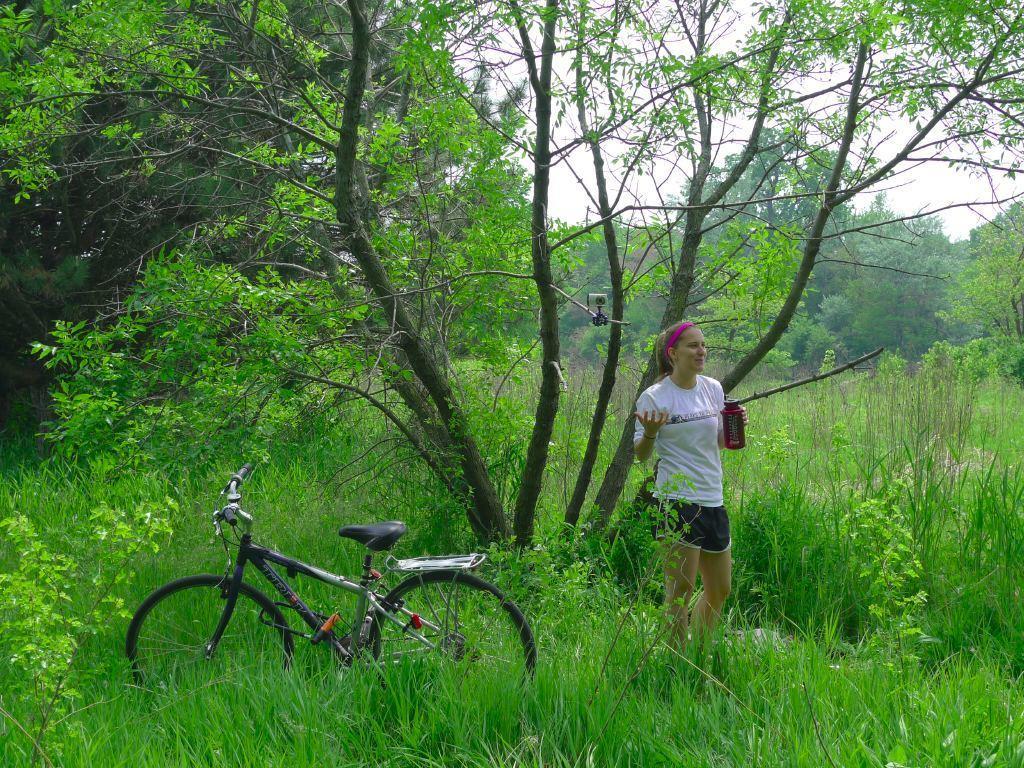Could you give a brief overview of what you see in this image? In the foreground of this image, there is a woman standing and holding a bottle on the grass and there is a bicycle. In the background, there are trees, grass, plants and the sky. 